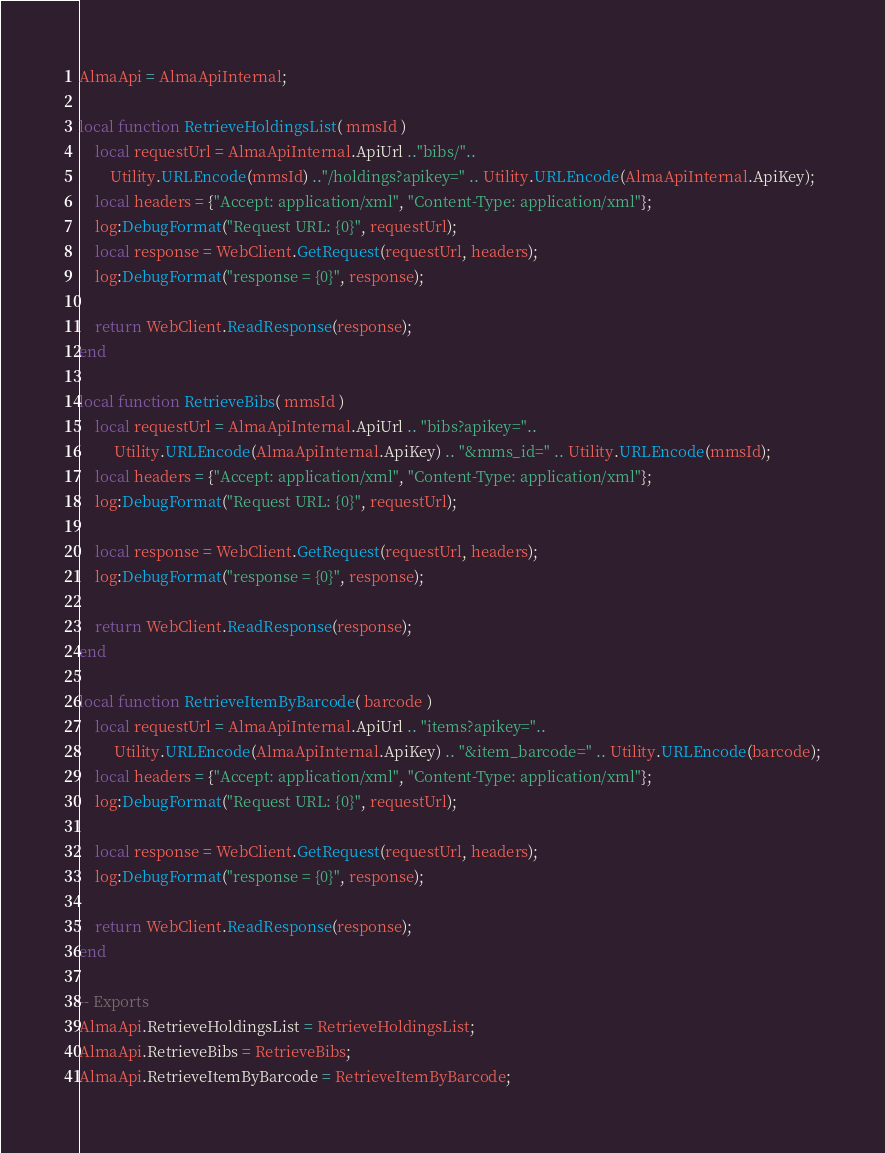Convert code to text. <code><loc_0><loc_0><loc_500><loc_500><_Lua_>
AlmaApi = AlmaApiInternal;

local function RetrieveHoldingsList( mmsId )
    local requestUrl = AlmaApiInternal.ApiUrl .."bibs/"..
        Utility.URLEncode(mmsId) .."/holdings?apikey=" .. Utility.URLEncode(AlmaApiInternal.ApiKey);
    local headers = {"Accept: application/xml", "Content-Type: application/xml"};
    log:DebugFormat("Request URL: {0}", requestUrl);
    local response = WebClient.GetRequest(requestUrl, headers);
    log:DebugFormat("response = {0}", response);

    return WebClient.ReadResponse(response);
end

local function RetrieveBibs( mmsId )
    local requestUrl = AlmaApiInternal.ApiUrl .. "bibs?apikey="..
         Utility.URLEncode(AlmaApiInternal.ApiKey) .. "&mms_id=" .. Utility.URLEncode(mmsId);
    local headers = {"Accept: application/xml", "Content-Type: application/xml"};
    log:DebugFormat("Request URL: {0}", requestUrl);

    local response = WebClient.GetRequest(requestUrl, headers);
    log:DebugFormat("response = {0}", response);

    return WebClient.ReadResponse(response);
end

local function RetrieveItemByBarcode( barcode )
    local requestUrl = AlmaApiInternal.ApiUrl .. "items?apikey="..
         Utility.URLEncode(AlmaApiInternal.ApiKey) .. "&item_barcode=" .. Utility.URLEncode(barcode);
    local headers = {"Accept: application/xml", "Content-Type: application/xml"};
    log:DebugFormat("Request URL: {0}", requestUrl);

    local response = WebClient.GetRequest(requestUrl, headers);
    log:DebugFormat("response = {0}", response);

    return WebClient.ReadResponse(response);
end

-- Exports
AlmaApi.RetrieveHoldingsList = RetrieveHoldingsList;
AlmaApi.RetrieveBibs = RetrieveBibs;
AlmaApi.RetrieveItemByBarcode = RetrieveItemByBarcode;</code> 